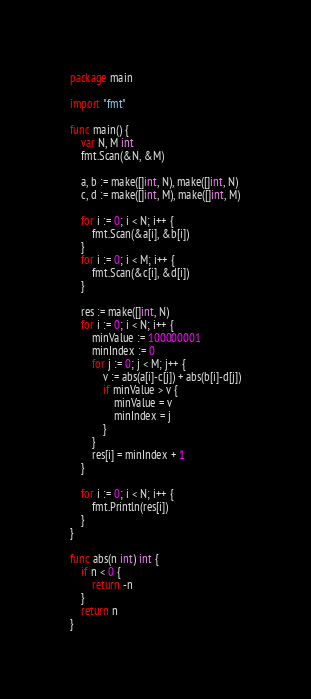<code> <loc_0><loc_0><loc_500><loc_500><_Go_>package main

import "fmt"

func main() {
	var N, M int
	fmt.Scan(&N, &M)

	a, b := make([]int, N), make([]int, N)
	c, d := make([]int, M), make([]int, M)

	for i := 0; i < N; i++ {
		fmt.Scan(&a[i], &b[i])
	}
	for i := 0; i < M; i++ {
		fmt.Scan(&c[i], &d[i])
	}

	res := make([]int, N)
	for i := 0; i < N; i++ {
		minValue := 100000001
		minIndex := 0
		for j := 0; j < M; j++ {
			v := abs(a[i]-c[j]) + abs(b[i]-d[j])
			if minValue > v {
				minValue = v
				minIndex = j
			}
		}
		res[i] = minIndex + 1
	}

	for i := 0; i < N; i++ {
		fmt.Println(res[i])
	}
}

func abs(n int) int {
	if n < 0 {
		return -n
	}
	return n
}
</code> 